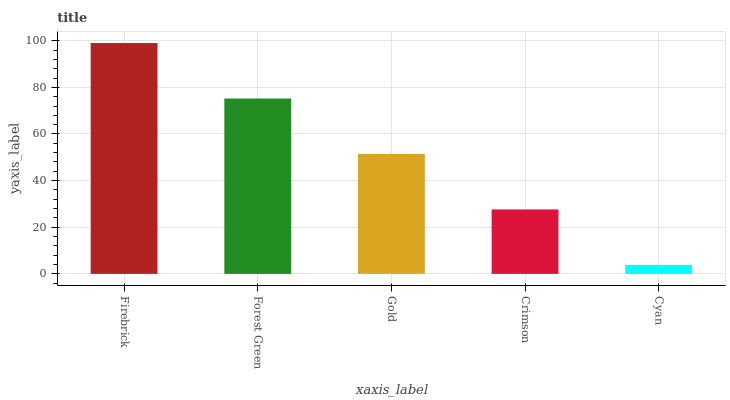Is Cyan the minimum?
Answer yes or no. Yes. Is Firebrick the maximum?
Answer yes or no. Yes. Is Forest Green the minimum?
Answer yes or no. No. Is Forest Green the maximum?
Answer yes or no. No. Is Firebrick greater than Forest Green?
Answer yes or no. Yes. Is Forest Green less than Firebrick?
Answer yes or no. Yes. Is Forest Green greater than Firebrick?
Answer yes or no. No. Is Firebrick less than Forest Green?
Answer yes or no. No. Is Gold the high median?
Answer yes or no. Yes. Is Gold the low median?
Answer yes or no. Yes. Is Cyan the high median?
Answer yes or no. No. Is Crimson the low median?
Answer yes or no. No. 